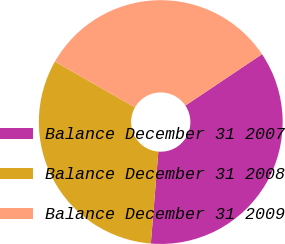<chart> <loc_0><loc_0><loc_500><loc_500><pie_chart><fcel>Balance December 31 2007<fcel>Balance December 31 2008<fcel>Balance December 31 2009<nl><fcel>35.7%<fcel>31.97%<fcel>32.34%<nl></chart> 